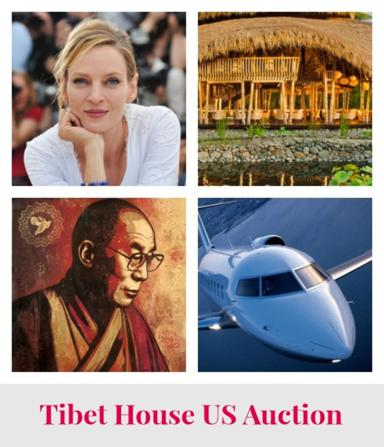What is the main subject of the image? The main subject of the image is the Tibet House US Auction. Can you describe the collage of photos in the image? The collage consists of photos of a woman, a man, and a plane. 